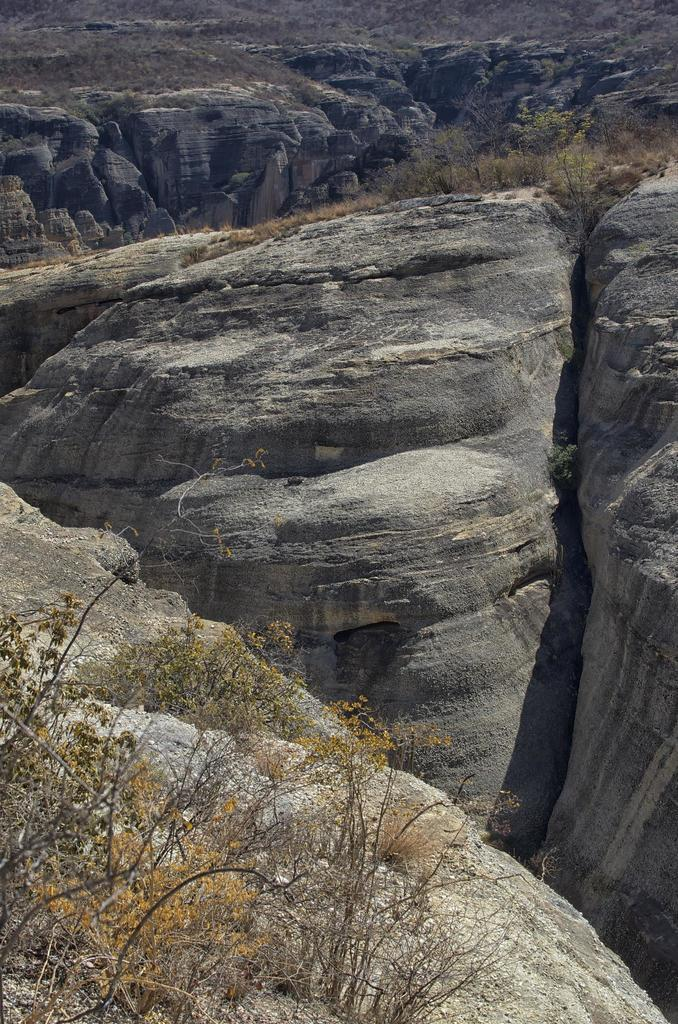What type of geological formation can be seen in the image? There are rock hills in the image. What type of vegetation is present in the image? There are trees in the image. What type of ground cover can be seen in the image? There is grass in the image. What type of agreement is being signed in the image? There is no indication of an agreement or any signing activity in the image. What title is being awarded to the person in the image? There is no indication of a title or any award ceremony in the image. 